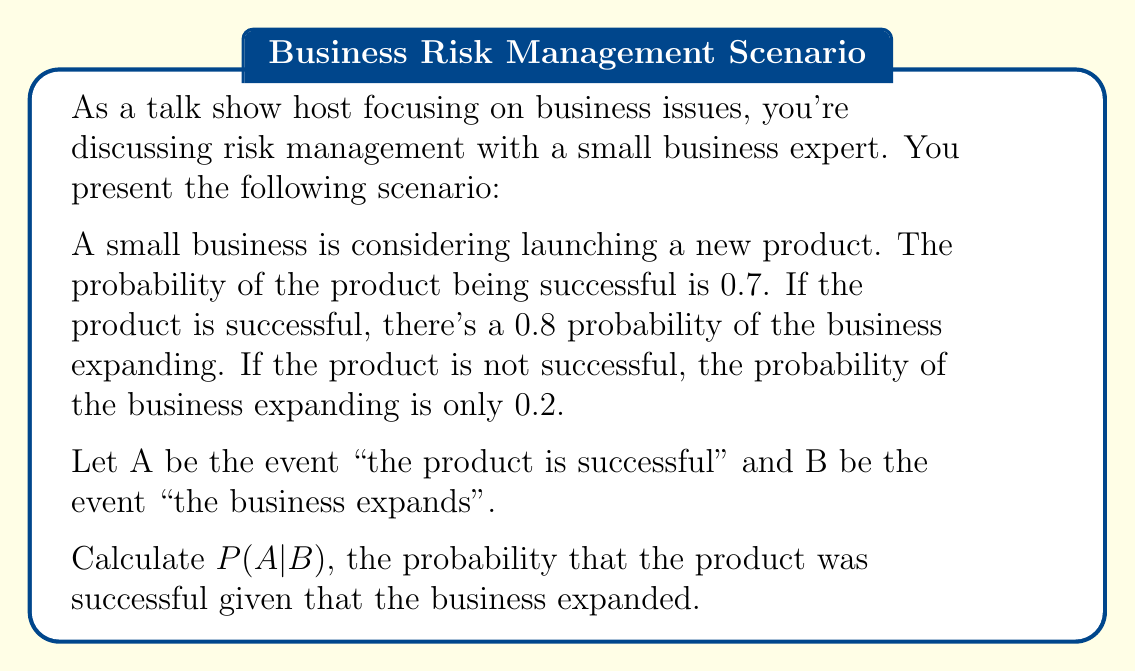What is the answer to this math problem? To solve this problem, we'll use Bayes' theorem, which is a conditional probability formula. The formula for Bayes' theorem is:

$$P(A|B) = \frac{P(B|A) \cdot P(A)}{P(B)}$$

We are given:
$P(A) = 0.7$ (probability of product success)
$P(B|A) = 0.8$ (probability of expansion given success)
$P(B|\text{not }A) = 0.2$ (probability of expansion given no success)

To find $P(B)$, we use the law of total probability:
$$P(B) = P(B|A) \cdot P(A) + P(B|\text{not }A) \cdot P(\text{not }A)$$

First, calculate $P(\text{not }A)$:
$P(\text{not }A) = 1 - P(A) = 1 - 0.7 = 0.3$

Now, calculate $P(B)$:
$$P(B) = 0.8 \cdot 0.7 + 0.2 \cdot 0.3 = 0.56 + 0.06 = 0.62$$

Now we have all the components to apply Bayes' theorem:

$$P(A|B) = \frac{0.8 \cdot 0.7}{0.62} = \frac{0.56}{0.62} = 0.9032$$
Answer: $P(A|B) \approx 0.9032$ or about 90.32% 